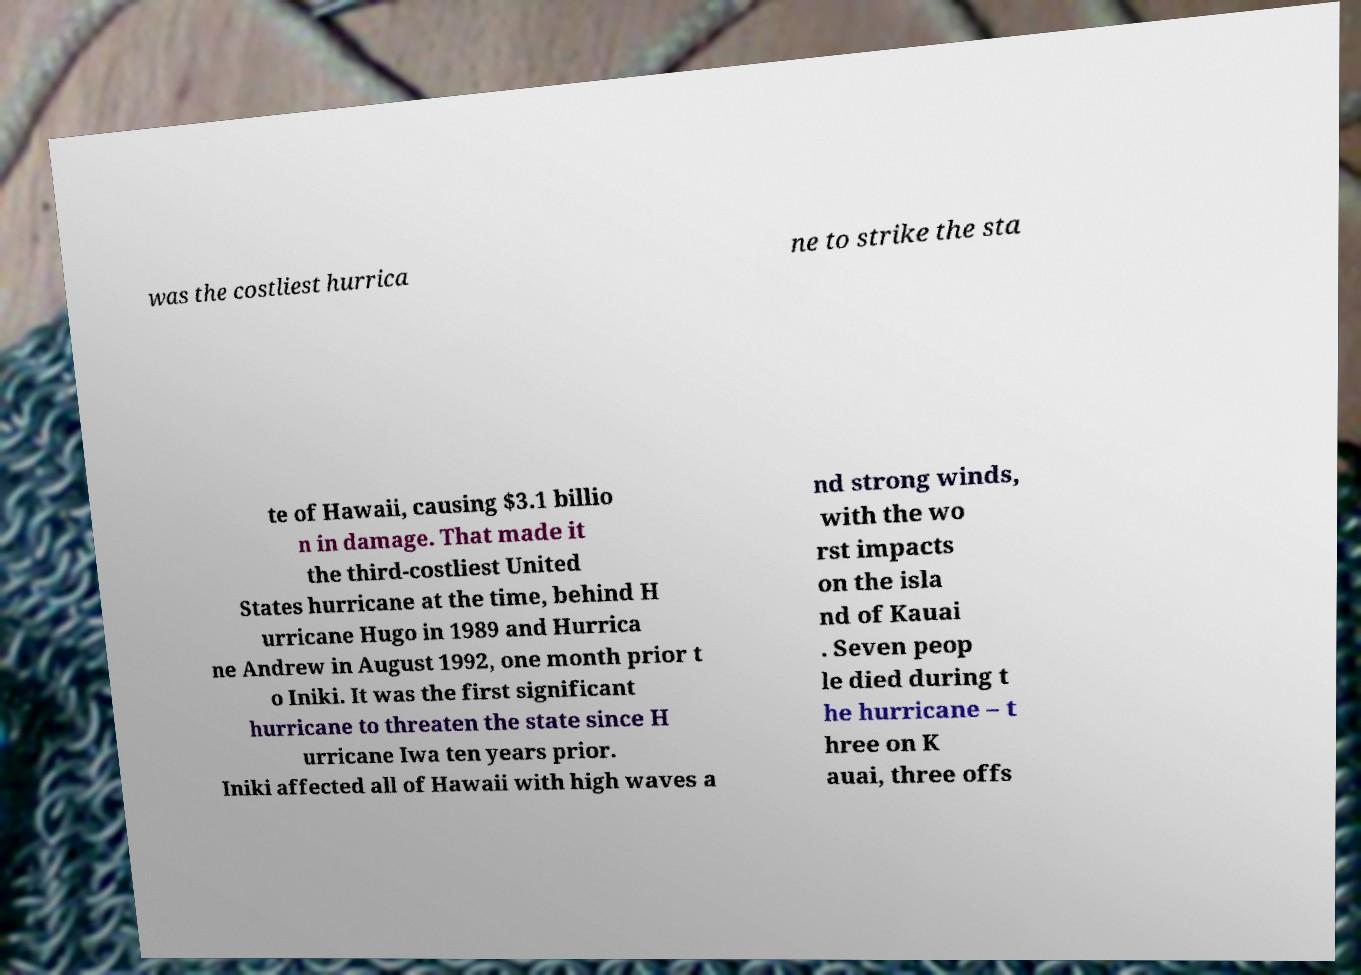Could you assist in decoding the text presented in this image and type it out clearly? was the costliest hurrica ne to strike the sta te of Hawaii, causing $3.1 billio n in damage. That made it the third-costliest United States hurricane at the time, behind H urricane Hugo in 1989 and Hurrica ne Andrew in August 1992, one month prior t o Iniki. It was the first significant hurricane to threaten the state since H urricane Iwa ten years prior. Iniki affected all of Hawaii with high waves a nd strong winds, with the wo rst impacts on the isla nd of Kauai . Seven peop le died during t he hurricane – t hree on K auai, three offs 